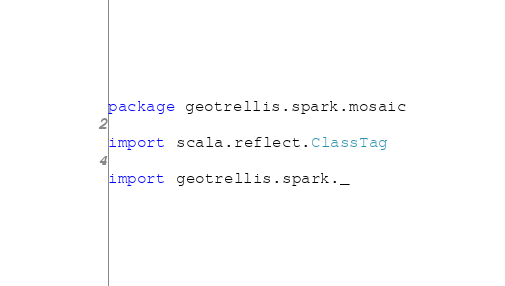<code> <loc_0><loc_0><loc_500><loc_500><_Scala_>package geotrellis.spark.mosaic

import scala.reflect.ClassTag

import geotrellis.spark._
</code> 